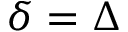Convert formula to latex. <formula><loc_0><loc_0><loc_500><loc_500>\delta = \Delta</formula> 